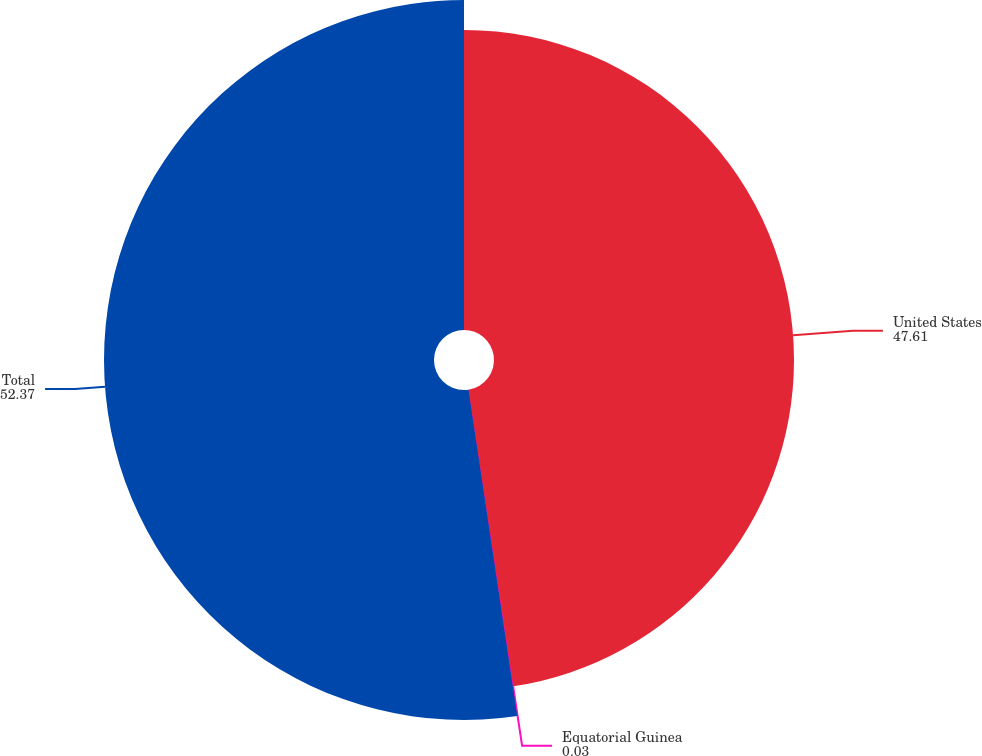Convert chart to OTSL. <chart><loc_0><loc_0><loc_500><loc_500><pie_chart><fcel>United States<fcel>Equatorial Guinea<fcel>Total<nl><fcel>47.61%<fcel>0.03%<fcel>52.37%<nl></chart> 